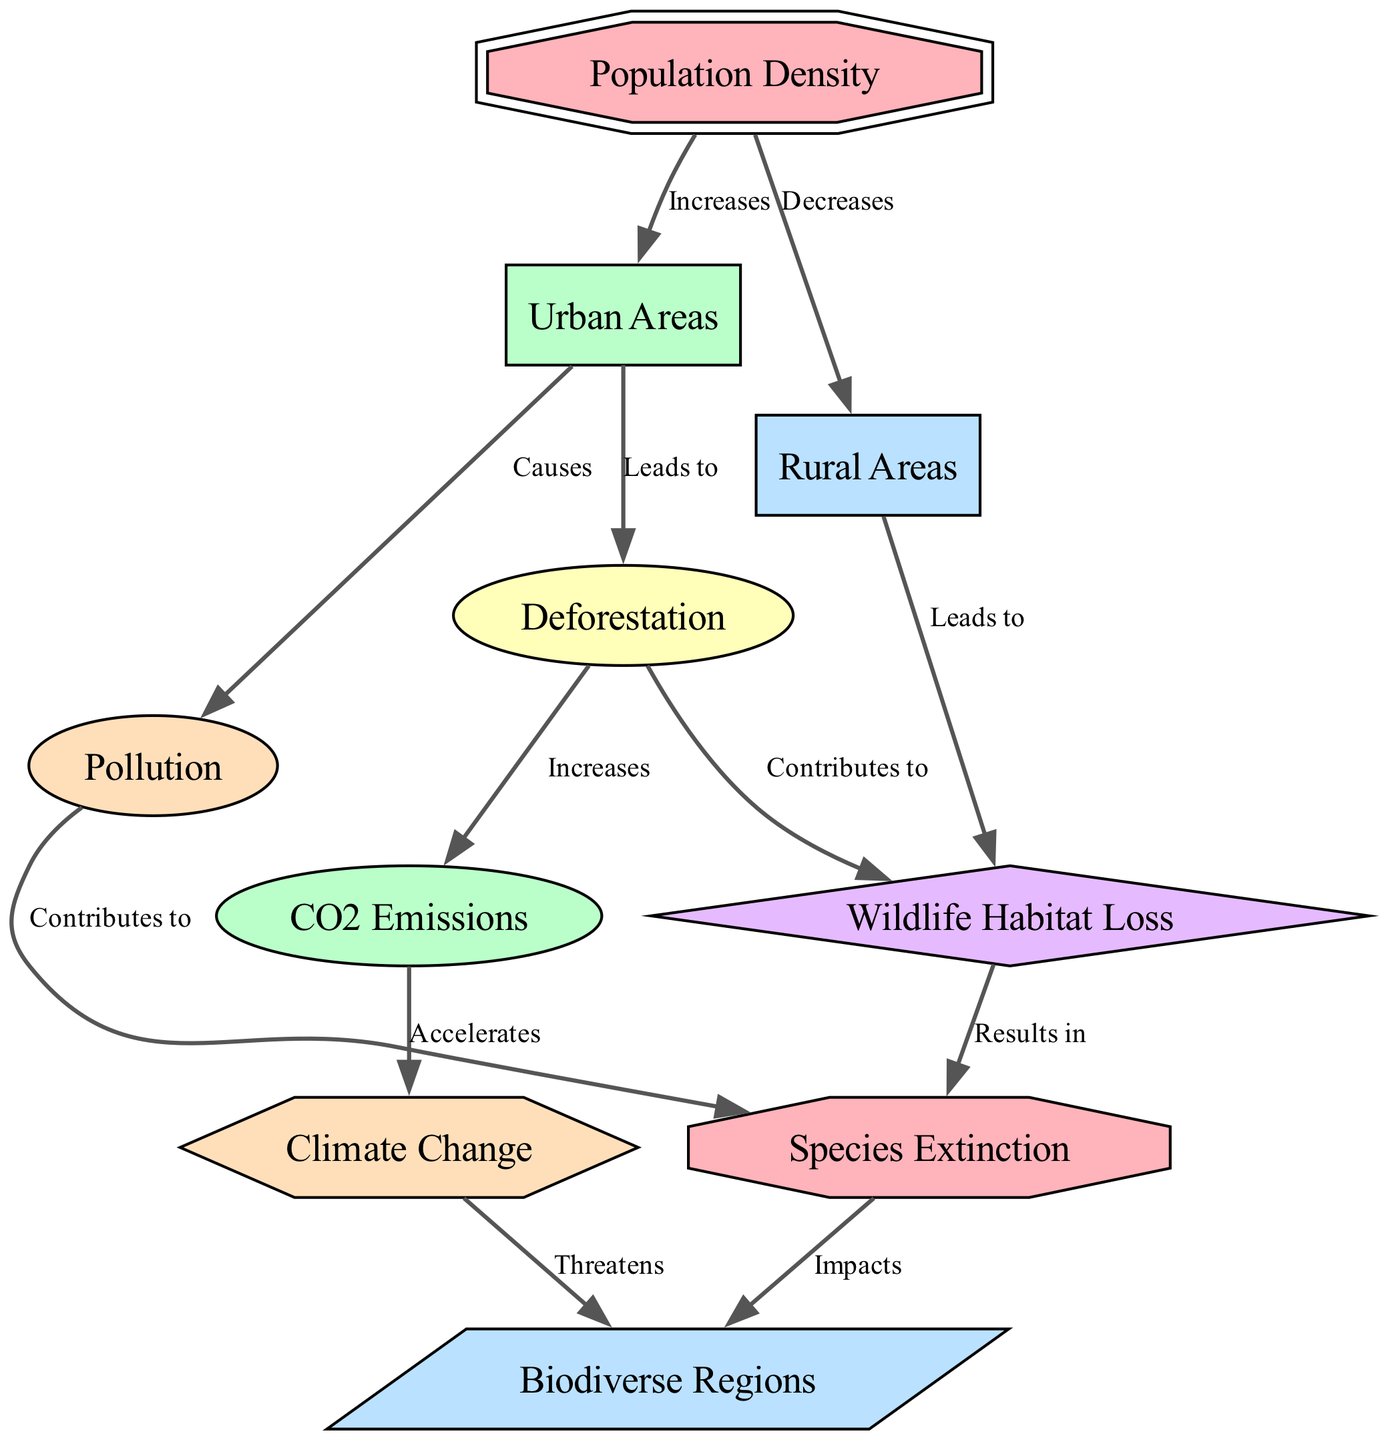What is the shape of the node representing "species extinction"? The diagram indicates that the node designated for "species extinction" is shaped like an octagon.
Answer: octagon How many nodes are present in the diagram? By counting the distinct nodes in the diagram, we find a total of ten unique entities or concepts represented within it.
Answer: ten What effect does "pollution" have on "species extinction"? According to the diagram, "pollution" contributes to "species extinction," as indicated by the labeled connection between these two nodes.
Answer: contributes to How is "urban areas" related to "deforestation"? The relationship shown in the diagram indicates that "urban areas" lead to an increase in "deforestation," establishing a direct cause-and-effect link.
Answer: leads to What impact does "climate change" have on "biodiverse regions"? The diagram illustrates that "climate change" threatens "biodiverse regions," highlighting a negative consequence for biodiversity due to climate-related changes.
Answer: threatens What is the relationship between "wildlife habitat loss" and "species extinction"? The diagram establishes that "wildlife habitat loss" results in "species extinction," indicating that the loss of habitat directly contributes to species disappearing.
Answer: results in Does "population density" increase or decrease in rural areas? Analyzing the diagram reveals that "population density" decreases in "rural areas," demonstrating a negative correlation in population distribution.
Answer: decreases Which node is impacted by both "co2 emissions" and "species extinction"? The arrow connections in the diagram indicate that "biodiverse regions" are affected by both "co2 emissions" and "species extinction," linking these environmental factors to biodiversity.
Answer: biodiverse regions What does "deforestation" contribute to regarding carbon levels? The diagram shows a connection where "deforestation" increases "co2 emissions," which indicates a direct relationship between these environmental processes.
Answer: increases 